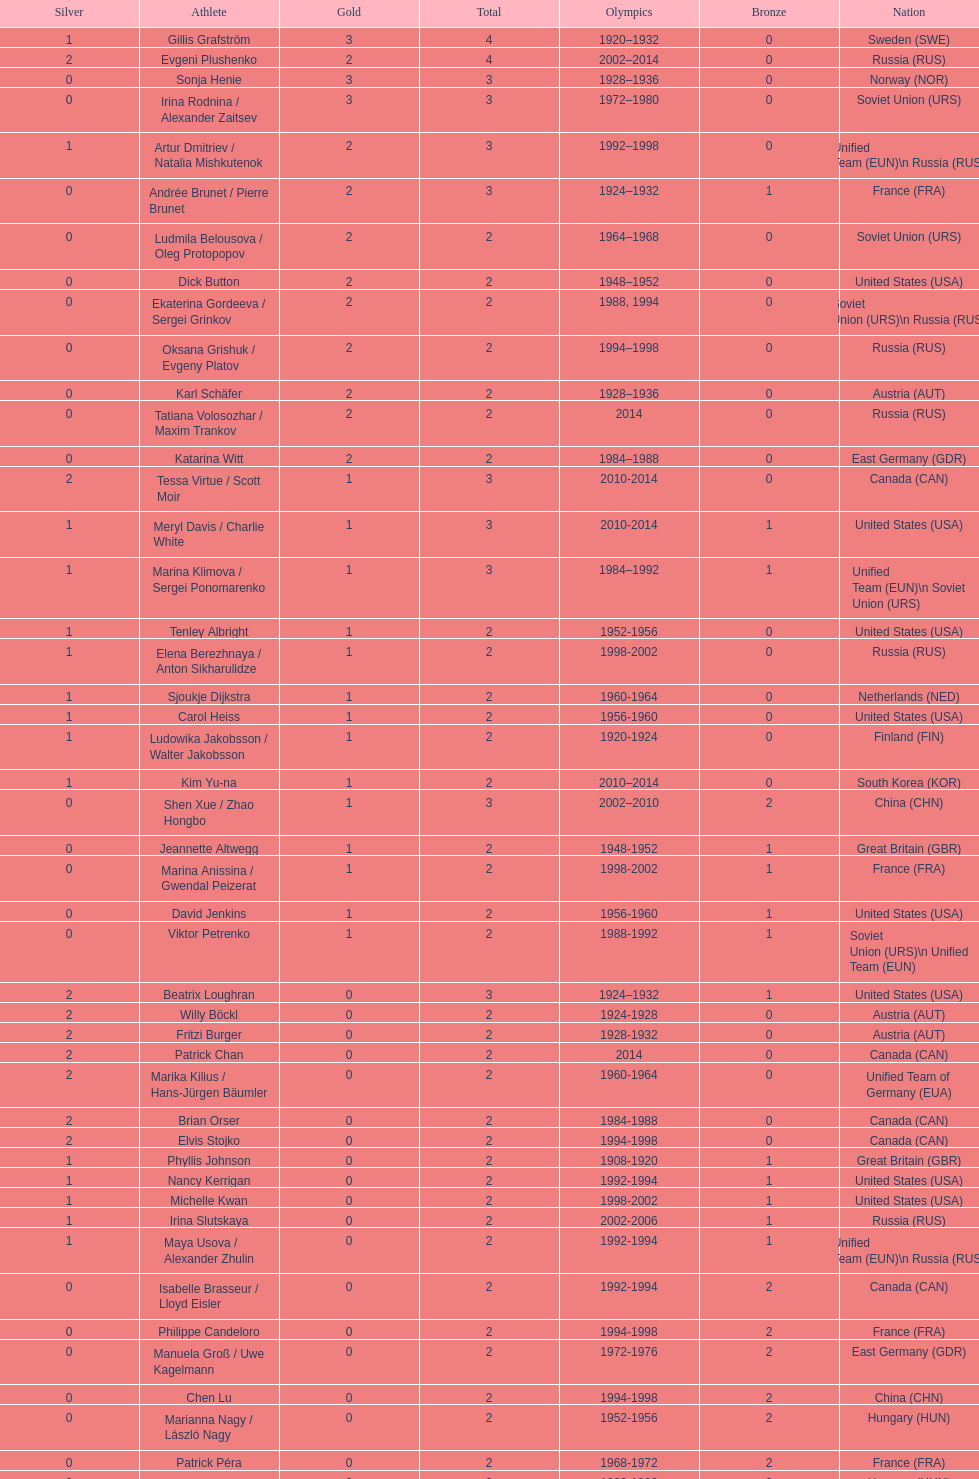Which athlete was from south korea after the year 2010? Kim Yu-na. 